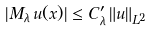Convert formula to latex. <formula><loc_0><loc_0><loc_500><loc_500>| M _ { \lambda } \, u ( x ) | \leq C ^ { \prime } _ { \lambda } \, \| u \| _ { L ^ { 2 } }</formula> 